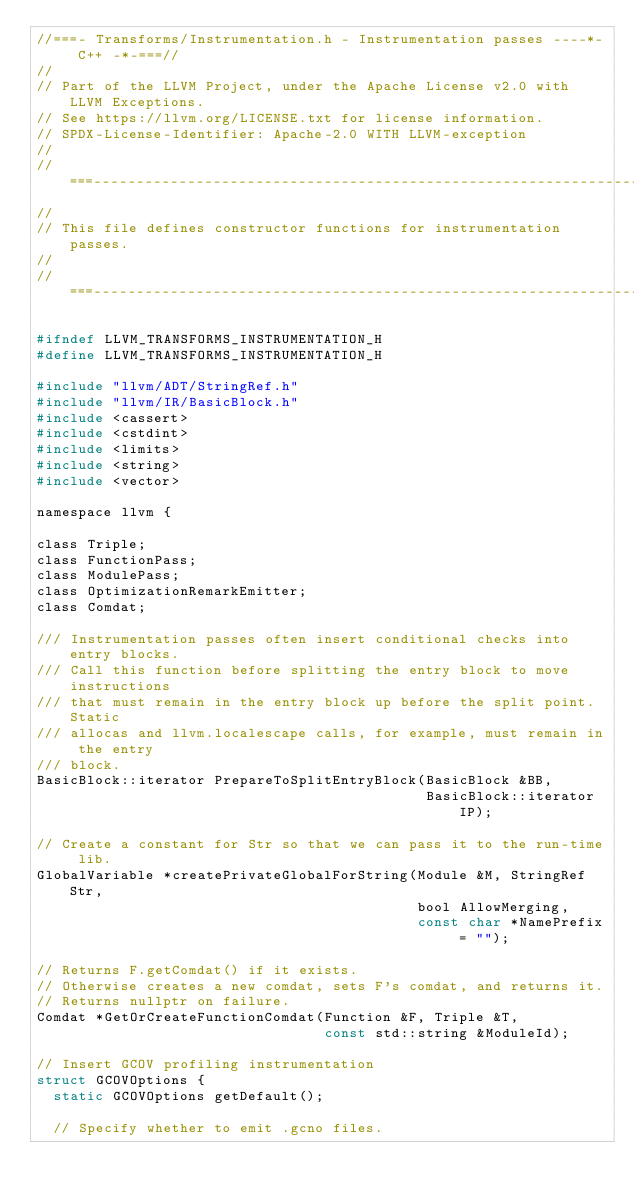Convert code to text. <code><loc_0><loc_0><loc_500><loc_500><_C_>//===- Transforms/Instrumentation.h - Instrumentation passes ----*- C++ -*-===//
//
// Part of the LLVM Project, under the Apache License v2.0 with LLVM Exceptions.
// See https://llvm.org/LICENSE.txt for license information.
// SPDX-License-Identifier: Apache-2.0 WITH LLVM-exception
//
//===----------------------------------------------------------------------===//
//
// This file defines constructor functions for instrumentation passes.
//
//===----------------------------------------------------------------------===//

#ifndef LLVM_TRANSFORMS_INSTRUMENTATION_H
#define LLVM_TRANSFORMS_INSTRUMENTATION_H

#include "llvm/ADT/StringRef.h"
#include "llvm/IR/BasicBlock.h"
#include <cassert>
#include <cstdint>
#include <limits>
#include <string>
#include <vector>

namespace llvm {

class Triple;
class FunctionPass;
class ModulePass;
class OptimizationRemarkEmitter;
class Comdat;

/// Instrumentation passes often insert conditional checks into entry blocks.
/// Call this function before splitting the entry block to move instructions
/// that must remain in the entry block up before the split point. Static
/// allocas and llvm.localescape calls, for example, must remain in the entry
/// block.
BasicBlock::iterator PrepareToSplitEntryBlock(BasicBlock &BB,
                                              BasicBlock::iterator IP);

// Create a constant for Str so that we can pass it to the run-time lib.
GlobalVariable *createPrivateGlobalForString(Module &M, StringRef Str,
                                             bool AllowMerging,
                                             const char *NamePrefix = "");

// Returns F.getComdat() if it exists.
// Otherwise creates a new comdat, sets F's comdat, and returns it.
// Returns nullptr on failure.
Comdat *GetOrCreateFunctionComdat(Function &F, Triple &T,
                                  const std::string &ModuleId);

// Insert GCOV profiling instrumentation
struct GCOVOptions {
  static GCOVOptions getDefault();

  // Specify whether to emit .gcno files.</code> 